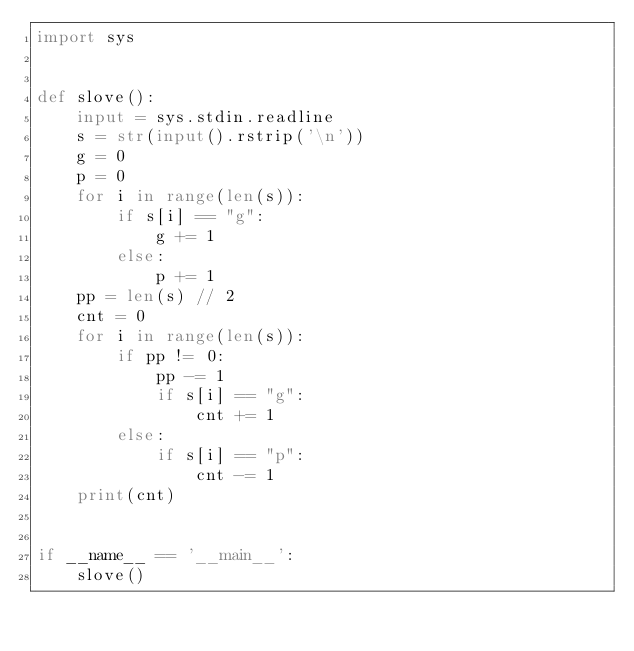<code> <loc_0><loc_0><loc_500><loc_500><_Python_>import sys


def slove():
    input = sys.stdin.readline
    s = str(input().rstrip('\n'))
    g = 0
    p = 0
    for i in range(len(s)):
        if s[i] == "g":
            g += 1
        else:
            p += 1
    pp = len(s) // 2
    cnt = 0
    for i in range(len(s)):
        if pp != 0:
            pp -= 1
            if s[i] == "g":
                cnt += 1
        else:
            if s[i] == "p":
                cnt -= 1
    print(cnt)


if __name__ == '__main__':
    slove()
</code> 